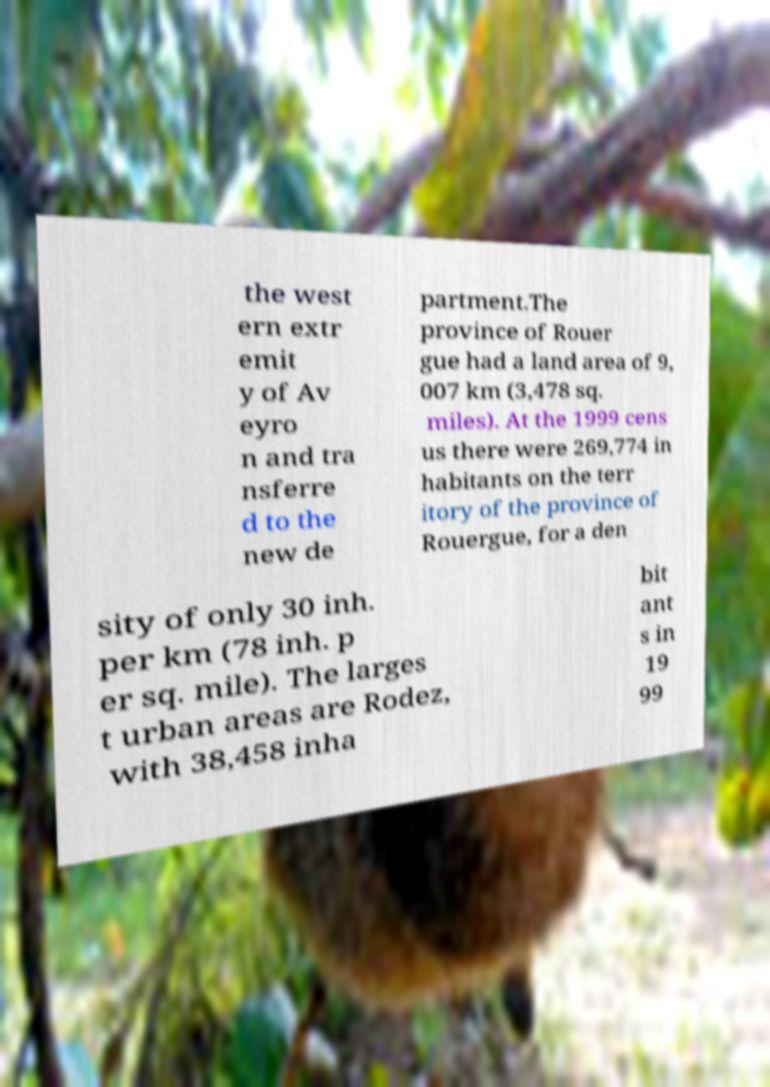There's text embedded in this image that I need extracted. Can you transcribe it verbatim? the west ern extr emit y of Av eyro n and tra nsferre d to the new de partment.The province of Rouer gue had a land area of 9, 007 km (3,478 sq. miles). At the 1999 cens us there were 269,774 in habitants on the terr itory of the province of Rouergue, for a den sity of only 30 inh. per km (78 inh. p er sq. mile). The larges t urban areas are Rodez, with 38,458 inha bit ant s in 19 99 